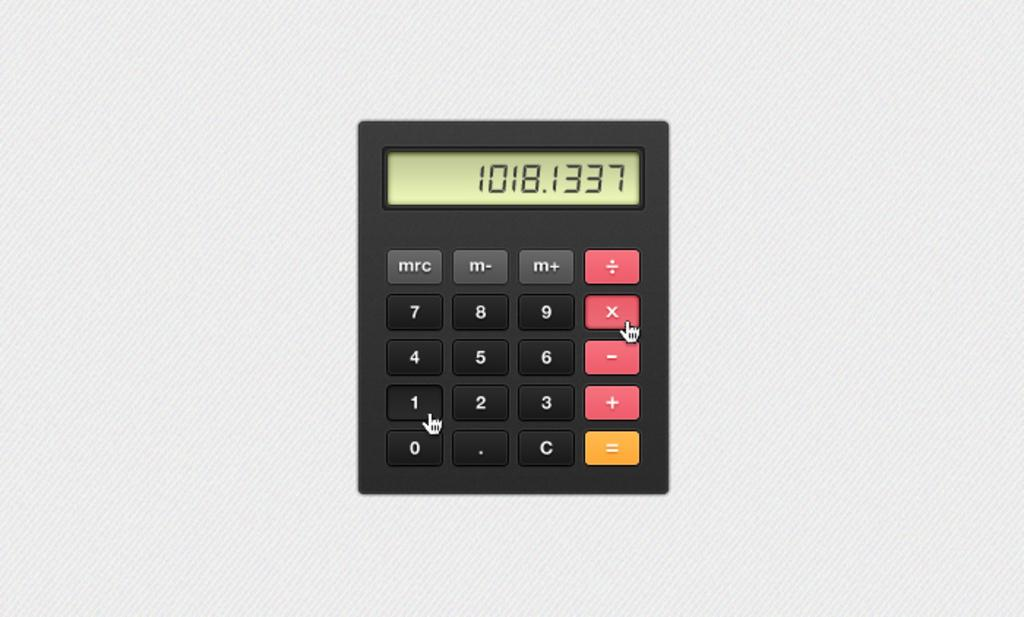<image>
Provide a brief description of the given image. A black calculator with the number 1018.1337 displayed. 